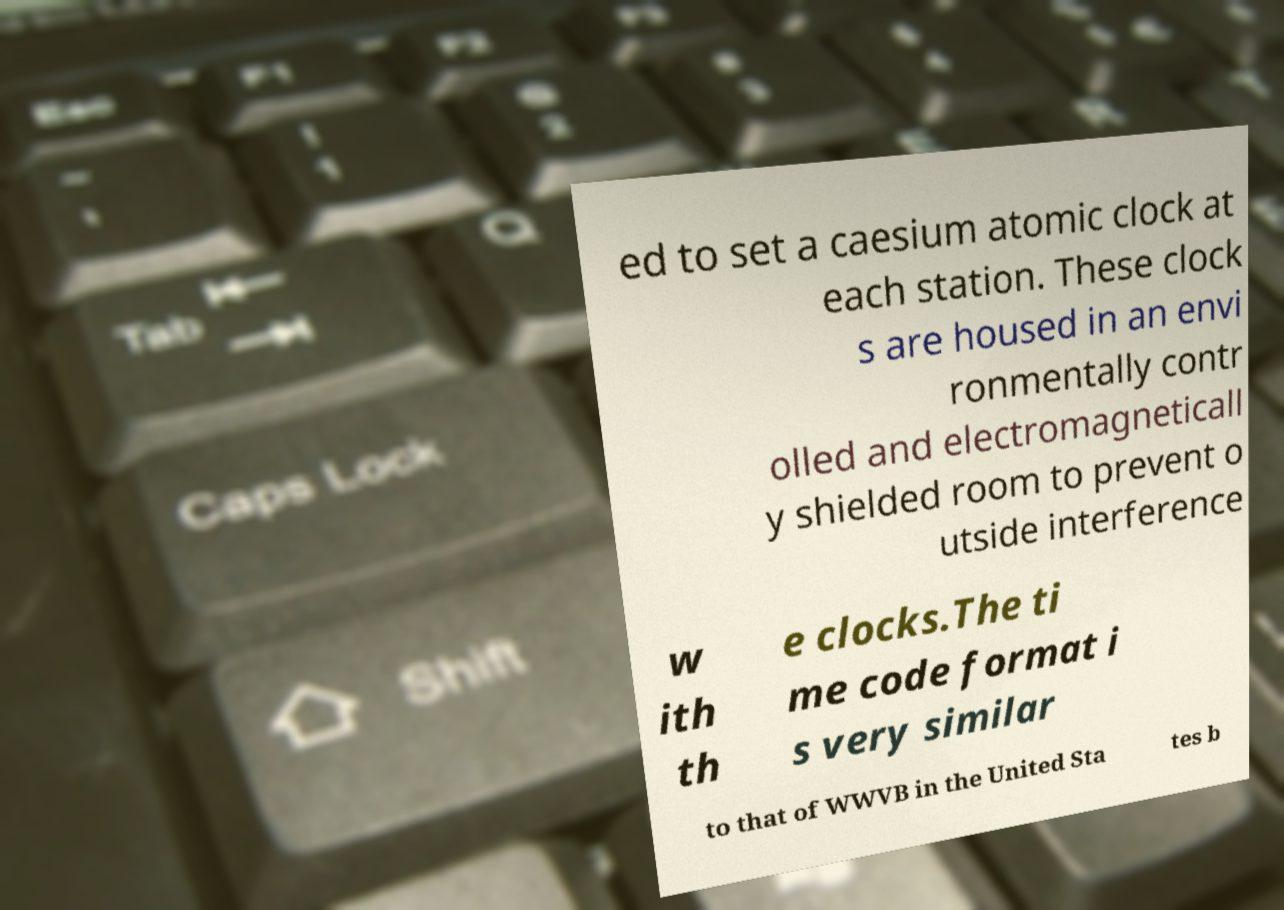I need the written content from this picture converted into text. Can you do that? ed to set a caesium atomic clock at each station. These clock s are housed in an envi ronmentally contr olled and electromagneticall y shielded room to prevent o utside interference w ith th e clocks.The ti me code format i s very similar to that of WWVB in the United Sta tes b 